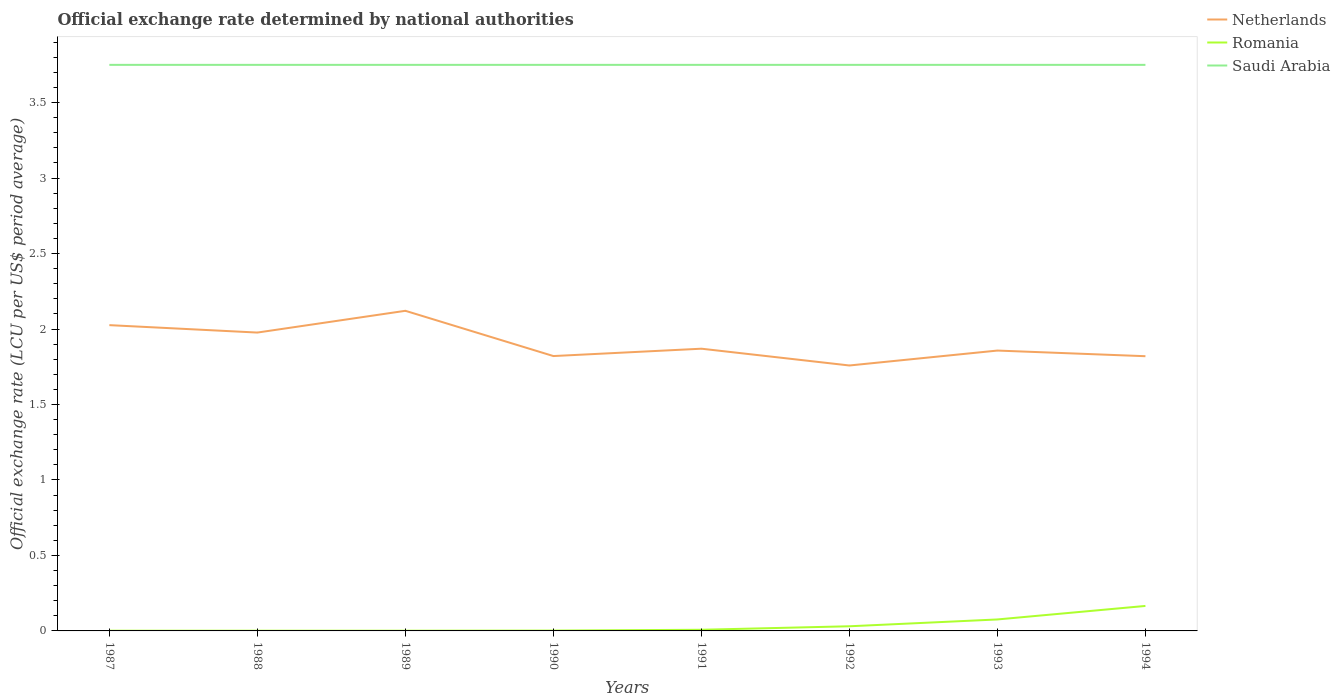Does the line corresponding to Saudi Arabia intersect with the line corresponding to Romania?
Offer a very short reply. No. Is the number of lines equal to the number of legend labels?
Provide a succinct answer. Yes. Across all years, what is the maximum official exchange rate in Netherlands?
Offer a very short reply. 1.76. What is the total official exchange rate in Netherlands in the graph?
Keep it short and to the point. -0.06. What is the difference between the highest and the second highest official exchange rate in Saudi Arabia?
Provide a succinct answer. 0. What is the difference between the highest and the lowest official exchange rate in Netherlands?
Your response must be concise. 3. Is the official exchange rate in Netherlands strictly greater than the official exchange rate in Romania over the years?
Offer a terse response. No. Are the values on the major ticks of Y-axis written in scientific E-notation?
Keep it short and to the point. No. Does the graph contain any zero values?
Provide a short and direct response. No. Does the graph contain grids?
Your answer should be very brief. No. Where does the legend appear in the graph?
Your answer should be very brief. Top right. How are the legend labels stacked?
Offer a terse response. Vertical. What is the title of the graph?
Give a very brief answer. Official exchange rate determined by national authorities. What is the label or title of the X-axis?
Provide a succinct answer. Years. What is the label or title of the Y-axis?
Ensure brevity in your answer.  Official exchange rate (LCU per US$ period average). What is the Official exchange rate (LCU per US$ period average) in Netherlands in 1987?
Your response must be concise. 2.03. What is the Official exchange rate (LCU per US$ period average) of Romania in 1987?
Give a very brief answer. 0. What is the Official exchange rate (LCU per US$ period average) of Saudi Arabia in 1987?
Ensure brevity in your answer.  3.75. What is the Official exchange rate (LCU per US$ period average) in Netherlands in 1988?
Offer a terse response. 1.98. What is the Official exchange rate (LCU per US$ period average) of Romania in 1988?
Your answer should be very brief. 0. What is the Official exchange rate (LCU per US$ period average) in Saudi Arabia in 1988?
Ensure brevity in your answer.  3.75. What is the Official exchange rate (LCU per US$ period average) in Netherlands in 1989?
Your response must be concise. 2.12. What is the Official exchange rate (LCU per US$ period average) in Romania in 1989?
Your response must be concise. 0. What is the Official exchange rate (LCU per US$ period average) in Saudi Arabia in 1989?
Your response must be concise. 3.75. What is the Official exchange rate (LCU per US$ period average) of Netherlands in 1990?
Your response must be concise. 1.82. What is the Official exchange rate (LCU per US$ period average) in Romania in 1990?
Your answer should be compact. 0. What is the Official exchange rate (LCU per US$ period average) in Saudi Arabia in 1990?
Offer a very short reply. 3.75. What is the Official exchange rate (LCU per US$ period average) of Netherlands in 1991?
Provide a short and direct response. 1.87. What is the Official exchange rate (LCU per US$ period average) of Romania in 1991?
Your answer should be very brief. 0.01. What is the Official exchange rate (LCU per US$ period average) of Saudi Arabia in 1991?
Give a very brief answer. 3.75. What is the Official exchange rate (LCU per US$ period average) in Netherlands in 1992?
Your response must be concise. 1.76. What is the Official exchange rate (LCU per US$ period average) in Romania in 1992?
Keep it short and to the point. 0.03. What is the Official exchange rate (LCU per US$ period average) of Saudi Arabia in 1992?
Make the answer very short. 3.75. What is the Official exchange rate (LCU per US$ period average) in Netherlands in 1993?
Make the answer very short. 1.86. What is the Official exchange rate (LCU per US$ period average) in Romania in 1993?
Ensure brevity in your answer.  0.08. What is the Official exchange rate (LCU per US$ period average) in Saudi Arabia in 1993?
Your answer should be compact. 3.75. What is the Official exchange rate (LCU per US$ period average) in Netherlands in 1994?
Provide a succinct answer. 1.82. What is the Official exchange rate (LCU per US$ period average) in Romania in 1994?
Keep it short and to the point. 0.17. What is the Official exchange rate (LCU per US$ period average) in Saudi Arabia in 1994?
Your response must be concise. 3.75. Across all years, what is the maximum Official exchange rate (LCU per US$ period average) in Netherlands?
Provide a short and direct response. 2.12. Across all years, what is the maximum Official exchange rate (LCU per US$ period average) in Romania?
Offer a terse response. 0.17. Across all years, what is the maximum Official exchange rate (LCU per US$ period average) of Saudi Arabia?
Your response must be concise. 3.75. Across all years, what is the minimum Official exchange rate (LCU per US$ period average) of Netherlands?
Your response must be concise. 1.76. Across all years, what is the minimum Official exchange rate (LCU per US$ period average) in Romania?
Keep it short and to the point. 0. Across all years, what is the minimum Official exchange rate (LCU per US$ period average) in Saudi Arabia?
Keep it short and to the point. 3.75. What is the total Official exchange rate (LCU per US$ period average) in Netherlands in the graph?
Your answer should be compact. 15.25. What is the total Official exchange rate (LCU per US$ period average) of Romania in the graph?
Make the answer very short. 0.29. What is the total Official exchange rate (LCU per US$ period average) in Saudi Arabia in the graph?
Offer a terse response. 30. What is the difference between the Official exchange rate (LCU per US$ period average) of Netherlands in 1987 and that in 1988?
Give a very brief answer. 0.05. What is the difference between the Official exchange rate (LCU per US$ period average) in Romania in 1987 and that in 1988?
Make the answer very short. 0. What is the difference between the Official exchange rate (LCU per US$ period average) of Netherlands in 1987 and that in 1989?
Your answer should be very brief. -0.1. What is the difference between the Official exchange rate (LCU per US$ period average) of Romania in 1987 and that in 1989?
Keep it short and to the point. -0. What is the difference between the Official exchange rate (LCU per US$ period average) in Saudi Arabia in 1987 and that in 1989?
Ensure brevity in your answer.  0. What is the difference between the Official exchange rate (LCU per US$ period average) in Netherlands in 1987 and that in 1990?
Give a very brief answer. 0.2. What is the difference between the Official exchange rate (LCU per US$ period average) in Romania in 1987 and that in 1990?
Offer a terse response. -0. What is the difference between the Official exchange rate (LCU per US$ period average) in Saudi Arabia in 1987 and that in 1990?
Your response must be concise. 0. What is the difference between the Official exchange rate (LCU per US$ period average) of Netherlands in 1987 and that in 1991?
Make the answer very short. 0.16. What is the difference between the Official exchange rate (LCU per US$ period average) in Romania in 1987 and that in 1991?
Offer a terse response. -0.01. What is the difference between the Official exchange rate (LCU per US$ period average) of Netherlands in 1987 and that in 1992?
Offer a very short reply. 0.27. What is the difference between the Official exchange rate (LCU per US$ period average) in Romania in 1987 and that in 1992?
Ensure brevity in your answer.  -0.03. What is the difference between the Official exchange rate (LCU per US$ period average) in Netherlands in 1987 and that in 1993?
Your answer should be very brief. 0.17. What is the difference between the Official exchange rate (LCU per US$ period average) of Romania in 1987 and that in 1993?
Make the answer very short. -0.07. What is the difference between the Official exchange rate (LCU per US$ period average) of Netherlands in 1987 and that in 1994?
Provide a short and direct response. 0.21. What is the difference between the Official exchange rate (LCU per US$ period average) of Romania in 1987 and that in 1994?
Give a very brief answer. -0.16. What is the difference between the Official exchange rate (LCU per US$ period average) of Saudi Arabia in 1987 and that in 1994?
Give a very brief answer. 0. What is the difference between the Official exchange rate (LCU per US$ period average) of Netherlands in 1988 and that in 1989?
Your response must be concise. -0.14. What is the difference between the Official exchange rate (LCU per US$ period average) of Romania in 1988 and that in 1989?
Give a very brief answer. -0. What is the difference between the Official exchange rate (LCU per US$ period average) of Netherlands in 1988 and that in 1990?
Offer a terse response. 0.16. What is the difference between the Official exchange rate (LCU per US$ period average) in Romania in 1988 and that in 1990?
Offer a terse response. -0. What is the difference between the Official exchange rate (LCU per US$ period average) in Netherlands in 1988 and that in 1991?
Offer a terse response. 0.11. What is the difference between the Official exchange rate (LCU per US$ period average) in Romania in 1988 and that in 1991?
Ensure brevity in your answer.  -0.01. What is the difference between the Official exchange rate (LCU per US$ period average) of Saudi Arabia in 1988 and that in 1991?
Offer a terse response. 0. What is the difference between the Official exchange rate (LCU per US$ period average) in Netherlands in 1988 and that in 1992?
Your answer should be very brief. 0.22. What is the difference between the Official exchange rate (LCU per US$ period average) of Romania in 1988 and that in 1992?
Your response must be concise. -0.03. What is the difference between the Official exchange rate (LCU per US$ period average) in Saudi Arabia in 1988 and that in 1992?
Give a very brief answer. 0. What is the difference between the Official exchange rate (LCU per US$ period average) in Netherlands in 1988 and that in 1993?
Offer a terse response. 0.12. What is the difference between the Official exchange rate (LCU per US$ period average) in Romania in 1988 and that in 1993?
Your response must be concise. -0.07. What is the difference between the Official exchange rate (LCU per US$ period average) in Saudi Arabia in 1988 and that in 1993?
Your answer should be compact. 0. What is the difference between the Official exchange rate (LCU per US$ period average) in Netherlands in 1988 and that in 1994?
Your answer should be very brief. 0.16. What is the difference between the Official exchange rate (LCU per US$ period average) of Romania in 1988 and that in 1994?
Your answer should be compact. -0.16. What is the difference between the Official exchange rate (LCU per US$ period average) in Saudi Arabia in 1988 and that in 1994?
Make the answer very short. 0. What is the difference between the Official exchange rate (LCU per US$ period average) in Netherlands in 1989 and that in 1990?
Ensure brevity in your answer.  0.3. What is the difference between the Official exchange rate (LCU per US$ period average) of Romania in 1989 and that in 1990?
Provide a succinct answer. -0. What is the difference between the Official exchange rate (LCU per US$ period average) in Saudi Arabia in 1989 and that in 1990?
Provide a succinct answer. 0. What is the difference between the Official exchange rate (LCU per US$ period average) of Netherlands in 1989 and that in 1991?
Give a very brief answer. 0.25. What is the difference between the Official exchange rate (LCU per US$ period average) of Romania in 1989 and that in 1991?
Make the answer very short. -0.01. What is the difference between the Official exchange rate (LCU per US$ period average) of Saudi Arabia in 1989 and that in 1991?
Provide a short and direct response. 0. What is the difference between the Official exchange rate (LCU per US$ period average) in Netherlands in 1989 and that in 1992?
Make the answer very short. 0.36. What is the difference between the Official exchange rate (LCU per US$ period average) in Romania in 1989 and that in 1992?
Ensure brevity in your answer.  -0.03. What is the difference between the Official exchange rate (LCU per US$ period average) of Netherlands in 1989 and that in 1993?
Ensure brevity in your answer.  0.26. What is the difference between the Official exchange rate (LCU per US$ period average) in Romania in 1989 and that in 1993?
Your response must be concise. -0.07. What is the difference between the Official exchange rate (LCU per US$ period average) in Saudi Arabia in 1989 and that in 1993?
Make the answer very short. 0. What is the difference between the Official exchange rate (LCU per US$ period average) in Netherlands in 1989 and that in 1994?
Your response must be concise. 0.3. What is the difference between the Official exchange rate (LCU per US$ period average) in Romania in 1989 and that in 1994?
Ensure brevity in your answer.  -0.16. What is the difference between the Official exchange rate (LCU per US$ period average) in Saudi Arabia in 1989 and that in 1994?
Provide a succinct answer. 0. What is the difference between the Official exchange rate (LCU per US$ period average) in Netherlands in 1990 and that in 1991?
Offer a very short reply. -0.05. What is the difference between the Official exchange rate (LCU per US$ period average) of Romania in 1990 and that in 1991?
Provide a succinct answer. -0.01. What is the difference between the Official exchange rate (LCU per US$ period average) of Netherlands in 1990 and that in 1992?
Make the answer very short. 0.06. What is the difference between the Official exchange rate (LCU per US$ period average) of Romania in 1990 and that in 1992?
Your answer should be compact. -0.03. What is the difference between the Official exchange rate (LCU per US$ period average) of Saudi Arabia in 1990 and that in 1992?
Keep it short and to the point. 0. What is the difference between the Official exchange rate (LCU per US$ period average) in Netherlands in 1990 and that in 1993?
Offer a very short reply. -0.04. What is the difference between the Official exchange rate (LCU per US$ period average) in Romania in 1990 and that in 1993?
Your answer should be very brief. -0.07. What is the difference between the Official exchange rate (LCU per US$ period average) of Saudi Arabia in 1990 and that in 1993?
Offer a terse response. 0. What is the difference between the Official exchange rate (LCU per US$ period average) of Netherlands in 1990 and that in 1994?
Provide a succinct answer. 0. What is the difference between the Official exchange rate (LCU per US$ period average) in Romania in 1990 and that in 1994?
Give a very brief answer. -0.16. What is the difference between the Official exchange rate (LCU per US$ period average) of Saudi Arabia in 1990 and that in 1994?
Your response must be concise. 0. What is the difference between the Official exchange rate (LCU per US$ period average) in Netherlands in 1991 and that in 1992?
Your answer should be compact. 0.11. What is the difference between the Official exchange rate (LCU per US$ period average) in Romania in 1991 and that in 1992?
Offer a very short reply. -0.02. What is the difference between the Official exchange rate (LCU per US$ period average) in Saudi Arabia in 1991 and that in 1992?
Provide a short and direct response. 0. What is the difference between the Official exchange rate (LCU per US$ period average) of Netherlands in 1991 and that in 1993?
Your answer should be very brief. 0.01. What is the difference between the Official exchange rate (LCU per US$ period average) in Romania in 1991 and that in 1993?
Give a very brief answer. -0.07. What is the difference between the Official exchange rate (LCU per US$ period average) in Saudi Arabia in 1991 and that in 1993?
Your answer should be compact. 0. What is the difference between the Official exchange rate (LCU per US$ period average) in Netherlands in 1991 and that in 1994?
Your answer should be very brief. 0.05. What is the difference between the Official exchange rate (LCU per US$ period average) in Romania in 1991 and that in 1994?
Offer a very short reply. -0.16. What is the difference between the Official exchange rate (LCU per US$ period average) of Netherlands in 1992 and that in 1993?
Make the answer very short. -0.1. What is the difference between the Official exchange rate (LCU per US$ period average) in Romania in 1992 and that in 1993?
Your response must be concise. -0.05. What is the difference between the Official exchange rate (LCU per US$ period average) of Saudi Arabia in 1992 and that in 1993?
Ensure brevity in your answer.  0. What is the difference between the Official exchange rate (LCU per US$ period average) of Netherlands in 1992 and that in 1994?
Your answer should be very brief. -0.06. What is the difference between the Official exchange rate (LCU per US$ period average) in Romania in 1992 and that in 1994?
Make the answer very short. -0.13. What is the difference between the Official exchange rate (LCU per US$ period average) in Saudi Arabia in 1992 and that in 1994?
Keep it short and to the point. 0. What is the difference between the Official exchange rate (LCU per US$ period average) of Netherlands in 1993 and that in 1994?
Make the answer very short. 0.04. What is the difference between the Official exchange rate (LCU per US$ period average) in Romania in 1993 and that in 1994?
Offer a terse response. -0.09. What is the difference between the Official exchange rate (LCU per US$ period average) of Saudi Arabia in 1993 and that in 1994?
Give a very brief answer. 0. What is the difference between the Official exchange rate (LCU per US$ period average) in Netherlands in 1987 and the Official exchange rate (LCU per US$ period average) in Romania in 1988?
Your answer should be compact. 2.02. What is the difference between the Official exchange rate (LCU per US$ period average) of Netherlands in 1987 and the Official exchange rate (LCU per US$ period average) of Saudi Arabia in 1988?
Provide a succinct answer. -1.72. What is the difference between the Official exchange rate (LCU per US$ period average) in Romania in 1987 and the Official exchange rate (LCU per US$ period average) in Saudi Arabia in 1988?
Give a very brief answer. -3.75. What is the difference between the Official exchange rate (LCU per US$ period average) of Netherlands in 1987 and the Official exchange rate (LCU per US$ period average) of Romania in 1989?
Make the answer very short. 2.02. What is the difference between the Official exchange rate (LCU per US$ period average) of Netherlands in 1987 and the Official exchange rate (LCU per US$ period average) of Saudi Arabia in 1989?
Offer a very short reply. -1.72. What is the difference between the Official exchange rate (LCU per US$ period average) of Romania in 1987 and the Official exchange rate (LCU per US$ period average) of Saudi Arabia in 1989?
Keep it short and to the point. -3.75. What is the difference between the Official exchange rate (LCU per US$ period average) of Netherlands in 1987 and the Official exchange rate (LCU per US$ period average) of Romania in 1990?
Ensure brevity in your answer.  2.02. What is the difference between the Official exchange rate (LCU per US$ period average) in Netherlands in 1987 and the Official exchange rate (LCU per US$ period average) in Saudi Arabia in 1990?
Make the answer very short. -1.72. What is the difference between the Official exchange rate (LCU per US$ period average) in Romania in 1987 and the Official exchange rate (LCU per US$ period average) in Saudi Arabia in 1990?
Ensure brevity in your answer.  -3.75. What is the difference between the Official exchange rate (LCU per US$ period average) in Netherlands in 1987 and the Official exchange rate (LCU per US$ period average) in Romania in 1991?
Provide a succinct answer. 2.02. What is the difference between the Official exchange rate (LCU per US$ period average) of Netherlands in 1987 and the Official exchange rate (LCU per US$ period average) of Saudi Arabia in 1991?
Ensure brevity in your answer.  -1.72. What is the difference between the Official exchange rate (LCU per US$ period average) of Romania in 1987 and the Official exchange rate (LCU per US$ period average) of Saudi Arabia in 1991?
Your response must be concise. -3.75. What is the difference between the Official exchange rate (LCU per US$ period average) of Netherlands in 1987 and the Official exchange rate (LCU per US$ period average) of Romania in 1992?
Give a very brief answer. 1.99. What is the difference between the Official exchange rate (LCU per US$ period average) of Netherlands in 1987 and the Official exchange rate (LCU per US$ period average) of Saudi Arabia in 1992?
Your response must be concise. -1.72. What is the difference between the Official exchange rate (LCU per US$ period average) in Romania in 1987 and the Official exchange rate (LCU per US$ period average) in Saudi Arabia in 1992?
Offer a terse response. -3.75. What is the difference between the Official exchange rate (LCU per US$ period average) of Netherlands in 1987 and the Official exchange rate (LCU per US$ period average) of Romania in 1993?
Your response must be concise. 1.95. What is the difference between the Official exchange rate (LCU per US$ period average) in Netherlands in 1987 and the Official exchange rate (LCU per US$ period average) in Saudi Arabia in 1993?
Provide a short and direct response. -1.72. What is the difference between the Official exchange rate (LCU per US$ period average) in Romania in 1987 and the Official exchange rate (LCU per US$ period average) in Saudi Arabia in 1993?
Offer a very short reply. -3.75. What is the difference between the Official exchange rate (LCU per US$ period average) of Netherlands in 1987 and the Official exchange rate (LCU per US$ period average) of Romania in 1994?
Offer a very short reply. 1.86. What is the difference between the Official exchange rate (LCU per US$ period average) in Netherlands in 1987 and the Official exchange rate (LCU per US$ period average) in Saudi Arabia in 1994?
Give a very brief answer. -1.72. What is the difference between the Official exchange rate (LCU per US$ period average) of Romania in 1987 and the Official exchange rate (LCU per US$ period average) of Saudi Arabia in 1994?
Your answer should be compact. -3.75. What is the difference between the Official exchange rate (LCU per US$ period average) of Netherlands in 1988 and the Official exchange rate (LCU per US$ period average) of Romania in 1989?
Provide a succinct answer. 1.98. What is the difference between the Official exchange rate (LCU per US$ period average) in Netherlands in 1988 and the Official exchange rate (LCU per US$ period average) in Saudi Arabia in 1989?
Provide a succinct answer. -1.77. What is the difference between the Official exchange rate (LCU per US$ period average) in Romania in 1988 and the Official exchange rate (LCU per US$ period average) in Saudi Arabia in 1989?
Offer a terse response. -3.75. What is the difference between the Official exchange rate (LCU per US$ period average) of Netherlands in 1988 and the Official exchange rate (LCU per US$ period average) of Romania in 1990?
Your answer should be very brief. 1.97. What is the difference between the Official exchange rate (LCU per US$ period average) of Netherlands in 1988 and the Official exchange rate (LCU per US$ period average) of Saudi Arabia in 1990?
Make the answer very short. -1.77. What is the difference between the Official exchange rate (LCU per US$ period average) in Romania in 1988 and the Official exchange rate (LCU per US$ period average) in Saudi Arabia in 1990?
Offer a terse response. -3.75. What is the difference between the Official exchange rate (LCU per US$ period average) of Netherlands in 1988 and the Official exchange rate (LCU per US$ period average) of Romania in 1991?
Your response must be concise. 1.97. What is the difference between the Official exchange rate (LCU per US$ period average) in Netherlands in 1988 and the Official exchange rate (LCU per US$ period average) in Saudi Arabia in 1991?
Your answer should be very brief. -1.77. What is the difference between the Official exchange rate (LCU per US$ period average) in Romania in 1988 and the Official exchange rate (LCU per US$ period average) in Saudi Arabia in 1991?
Your answer should be very brief. -3.75. What is the difference between the Official exchange rate (LCU per US$ period average) of Netherlands in 1988 and the Official exchange rate (LCU per US$ period average) of Romania in 1992?
Offer a very short reply. 1.95. What is the difference between the Official exchange rate (LCU per US$ period average) of Netherlands in 1988 and the Official exchange rate (LCU per US$ period average) of Saudi Arabia in 1992?
Make the answer very short. -1.77. What is the difference between the Official exchange rate (LCU per US$ period average) in Romania in 1988 and the Official exchange rate (LCU per US$ period average) in Saudi Arabia in 1992?
Your answer should be very brief. -3.75. What is the difference between the Official exchange rate (LCU per US$ period average) of Netherlands in 1988 and the Official exchange rate (LCU per US$ period average) of Romania in 1993?
Ensure brevity in your answer.  1.9. What is the difference between the Official exchange rate (LCU per US$ period average) in Netherlands in 1988 and the Official exchange rate (LCU per US$ period average) in Saudi Arabia in 1993?
Ensure brevity in your answer.  -1.77. What is the difference between the Official exchange rate (LCU per US$ period average) in Romania in 1988 and the Official exchange rate (LCU per US$ period average) in Saudi Arabia in 1993?
Ensure brevity in your answer.  -3.75. What is the difference between the Official exchange rate (LCU per US$ period average) of Netherlands in 1988 and the Official exchange rate (LCU per US$ period average) of Romania in 1994?
Your answer should be compact. 1.81. What is the difference between the Official exchange rate (LCU per US$ period average) in Netherlands in 1988 and the Official exchange rate (LCU per US$ period average) in Saudi Arabia in 1994?
Your answer should be compact. -1.77. What is the difference between the Official exchange rate (LCU per US$ period average) in Romania in 1988 and the Official exchange rate (LCU per US$ period average) in Saudi Arabia in 1994?
Your answer should be very brief. -3.75. What is the difference between the Official exchange rate (LCU per US$ period average) of Netherlands in 1989 and the Official exchange rate (LCU per US$ period average) of Romania in 1990?
Your answer should be very brief. 2.12. What is the difference between the Official exchange rate (LCU per US$ period average) in Netherlands in 1989 and the Official exchange rate (LCU per US$ period average) in Saudi Arabia in 1990?
Provide a succinct answer. -1.63. What is the difference between the Official exchange rate (LCU per US$ period average) of Romania in 1989 and the Official exchange rate (LCU per US$ period average) of Saudi Arabia in 1990?
Offer a very short reply. -3.75. What is the difference between the Official exchange rate (LCU per US$ period average) of Netherlands in 1989 and the Official exchange rate (LCU per US$ period average) of Romania in 1991?
Your response must be concise. 2.11. What is the difference between the Official exchange rate (LCU per US$ period average) of Netherlands in 1989 and the Official exchange rate (LCU per US$ period average) of Saudi Arabia in 1991?
Offer a terse response. -1.63. What is the difference between the Official exchange rate (LCU per US$ period average) in Romania in 1989 and the Official exchange rate (LCU per US$ period average) in Saudi Arabia in 1991?
Provide a succinct answer. -3.75. What is the difference between the Official exchange rate (LCU per US$ period average) in Netherlands in 1989 and the Official exchange rate (LCU per US$ period average) in Romania in 1992?
Provide a short and direct response. 2.09. What is the difference between the Official exchange rate (LCU per US$ period average) in Netherlands in 1989 and the Official exchange rate (LCU per US$ period average) in Saudi Arabia in 1992?
Your answer should be very brief. -1.63. What is the difference between the Official exchange rate (LCU per US$ period average) of Romania in 1989 and the Official exchange rate (LCU per US$ period average) of Saudi Arabia in 1992?
Offer a terse response. -3.75. What is the difference between the Official exchange rate (LCU per US$ period average) of Netherlands in 1989 and the Official exchange rate (LCU per US$ period average) of Romania in 1993?
Your answer should be compact. 2.04. What is the difference between the Official exchange rate (LCU per US$ period average) of Netherlands in 1989 and the Official exchange rate (LCU per US$ period average) of Saudi Arabia in 1993?
Give a very brief answer. -1.63. What is the difference between the Official exchange rate (LCU per US$ period average) of Romania in 1989 and the Official exchange rate (LCU per US$ period average) of Saudi Arabia in 1993?
Your response must be concise. -3.75. What is the difference between the Official exchange rate (LCU per US$ period average) of Netherlands in 1989 and the Official exchange rate (LCU per US$ period average) of Romania in 1994?
Ensure brevity in your answer.  1.96. What is the difference between the Official exchange rate (LCU per US$ period average) in Netherlands in 1989 and the Official exchange rate (LCU per US$ period average) in Saudi Arabia in 1994?
Offer a terse response. -1.63. What is the difference between the Official exchange rate (LCU per US$ period average) in Romania in 1989 and the Official exchange rate (LCU per US$ period average) in Saudi Arabia in 1994?
Keep it short and to the point. -3.75. What is the difference between the Official exchange rate (LCU per US$ period average) of Netherlands in 1990 and the Official exchange rate (LCU per US$ period average) of Romania in 1991?
Offer a very short reply. 1.81. What is the difference between the Official exchange rate (LCU per US$ period average) of Netherlands in 1990 and the Official exchange rate (LCU per US$ period average) of Saudi Arabia in 1991?
Your response must be concise. -1.93. What is the difference between the Official exchange rate (LCU per US$ period average) of Romania in 1990 and the Official exchange rate (LCU per US$ period average) of Saudi Arabia in 1991?
Provide a short and direct response. -3.75. What is the difference between the Official exchange rate (LCU per US$ period average) of Netherlands in 1990 and the Official exchange rate (LCU per US$ period average) of Romania in 1992?
Provide a short and direct response. 1.79. What is the difference between the Official exchange rate (LCU per US$ period average) of Netherlands in 1990 and the Official exchange rate (LCU per US$ period average) of Saudi Arabia in 1992?
Keep it short and to the point. -1.93. What is the difference between the Official exchange rate (LCU per US$ period average) of Romania in 1990 and the Official exchange rate (LCU per US$ period average) of Saudi Arabia in 1992?
Ensure brevity in your answer.  -3.75. What is the difference between the Official exchange rate (LCU per US$ period average) in Netherlands in 1990 and the Official exchange rate (LCU per US$ period average) in Romania in 1993?
Your response must be concise. 1.74. What is the difference between the Official exchange rate (LCU per US$ period average) in Netherlands in 1990 and the Official exchange rate (LCU per US$ period average) in Saudi Arabia in 1993?
Provide a succinct answer. -1.93. What is the difference between the Official exchange rate (LCU per US$ period average) in Romania in 1990 and the Official exchange rate (LCU per US$ period average) in Saudi Arabia in 1993?
Give a very brief answer. -3.75. What is the difference between the Official exchange rate (LCU per US$ period average) of Netherlands in 1990 and the Official exchange rate (LCU per US$ period average) of Romania in 1994?
Your answer should be compact. 1.66. What is the difference between the Official exchange rate (LCU per US$ period average) in Netherlands in 1990 and the Official exchange rate (LCU per US$ period average) in Saudi Arabia in 1994?
Provide a succinct answer. -1.93. What is the difference between the Official exchange rate (LCU per US$ period average) of Romania in 1990 and the Official exchange rate (LCU per US$ period average) of Saudi Arabia in 1994?
Provide a succinct answer. -3.75. What is the difference between the Official exchange rate (LCU per US$ period average) in Netherlands in 1991 and the Official exchange rate (LCU per US$ period average) in Romania in 1992?
Make the answer very short. 1.84. What is the difference between the Official exchange rate (LCU per US$ period average) in Netherlands in 1991 and the Official exchange rate (LCU per US$ period average) in Saudi Arabia in 1992?
Ensure brevity in your answer.  -1.88. What is the difference between the Official exchange rate (LCU per US$ period average) of Romania in 1991 and the Official exchange rate (LCU per US$ period average) of Saudi Arabia in 1992?
Give a very brief answer. -3.74. What is the difference between the Official exchange rate (LCU per US$ period average) of Netherlands in 1991 and the Official exchange rate (LCU per US$ period average) of Romania in 1993?
Offer a terse response. 1.79. What is the difference between the Official exchange rate (LCU per US$ period average) in Netherlands in 1991 and the Official exchange rate (LCU per US$ period average) in Saudi Arabia in 1993?
Offer a terse response. -1.88. What is the difference between the Official exchange rate (LCU per US$ period average) of Romania in 1991 and the Official exchange rate (LCU per US$ period average) of Saudi Arabia in 1993?
Offer a very short reply. -3.74. What is the difference between the Official exchange rate (LCU per US$ period average) of Netherlands in 1991 and the Official exchange rate (LCU per US$ period average) of Romania in 1994?
Make the answer very short. 1.7. What is the difference between the Official exchange rate (LCU per US$ period average) in Netherlands in 1991 and the Official exchange rate (LCU per US$ period average) in Saudi Arabia in 1994?
Provide a short and direct response. -1.88. What is the difference between the Official exchange rate (LCU per US$ period average) in Romania in 1991 and the Official exchange rate (LCU per US$ period average) in Saudi Arabia in 1994?
Provide a succinct answer. -3.74. What is the difference between the Official exchange rate (LCU per US$ period average) in Netherlands in 1992 and the Official exchange rate (LCU per US$ period average) in Romania in 1993?
Ensure brevity in your answer.  1.68. What is the difference between the Official exchange rate (LCU per US$ period average) of Netherlands in 1992 and the Official exchange rate (LCU per US$ period average) of Saudi Arabia in 1993?
Make the answer very short. -1.99. What is the difference between the Official exchange rate (LCU per US$ period average) in Romania in 1992 and the Official exchange rate (LCU per US$ period average) in Saudi Arabia in 1993?
Your answer should be very brief. -3.72. What is the difference between the Official exchange rate (LCU per US$ period average) of Netherlands in 1992 and the Official exchange rate (LCU per US$ period average) of Romania in 1994?
Offer a terse response. 1.59. What is the difference between the Official exchange rate (LCU per US$ period average) in Netherlands in 1992 and the Official exchange rate (LCU per US$ period average) in Saudi Arabia in 1994?
Give a very brief answer. -1.99. What is the difference between the Official exchange rate (LCU per US$ period average) in Romania in 1992 and the Official exchange rate (LCU per US$ period average) in Saudi Arabia in 1994?
Offer a very short reply. -3.72. What is the difference between the Official exchange rate (LCU per US$ period average) of Netherlands in 1993 and the Official exchange rate (LCU per US$ period average) of Romania in 1994?
Provide a short and direct response. 1.69. What is the difference between the Official exchange rate (LCU per US$ period average) in Netherlands in 1993 and the Official exchange rate (LCU per US$ period average) in Saudi Arabia in 1994?
Offer a terse response. -1.89. What is the difference between the Official exchange rate (LCU per US$ period average) of Romania in 1993 and the Official exchange rate (LCU per US$ period average) of Saudi Arabia in 1994?
Your response must be concise. -3.67. What is the average Official exchange rate (LCU per US$ period average) of Netherlands per year?
Keep it short and to the point. 1.91. What is the average Official exchange rate (LCU per US$ period average) in Romania per year?
Offer a very short reply. 0.04. What is the average Official exchange rate (LCU per US$ period average) of Saudi Arabia per year?
Offer a very short reply. 3.75. In the year 1987, what is the difference between the Official exchange rate (LCU per US$ period average) in Netherlands and Official exchange rate (LCU per US$ period average) in Romania?
Provide a short and direct response. 2.02. In the year 1987, what is the difference between the Official exchange rate (LCU per US$ period average) of Netherlands and Official exchange rate (LCU per US$ period average) of Saudi Arabia?
Provide a succinct answer. -1.72. In the year 1987, what is the difference between the Official exchange rate (LCU per US$ period average) of Romania and Official exchange rate (LCU per US$ period average) of Saudi Arabia?
Make the answer very short. -3.75. In the year 1988, what is the difference between the Official exchange rate (LCU per US$ period average) of Netherlands and Official exchange rate (LCU per US$ period average) of Romania?
Your answer should be very brief. 1.98. In the year 1988, what is the difference between the Official exchange rate (LCU per US$ period average) of Netherlands and Official exchange rate (LCU per US$ period average) of Saudi Arabia?
Your response must be concise. -1.77. In the year 1988, what is the difference between the Official exchange rate (LCU per US$ period average) of Romania and Official exchange rate (LCU per US$ period average) of Saudi Arabia?
Provide a succinct answer. -3.75. In the year 1989, what is the difference between the Official exchange rate (LCU per US$ period average) of Netherlands and Official exchange rate (LCU per US$ period average) of Romania?
Provide a succinct answer. 2.12. In the year 1989, what is the difference between the Official exchange rate (LCU per US$ period average) in Netherlands and Official exchange rate (LCU per US$ period average) in Saudi Arabia?
Your answer should be compact. -1.63. In the year 1989, what is the difference between the Official exchange rate (LCU per US$ period average) in Romania and Official exchange rate (LCU per US$ period average) in Saudi Arabia?
Give a very brief answer. -3.75. In the year 1990, what is the difference between the Official exchange rate (LCU per US$ period average) in Netherlands and Official exchange rate (LCU per US$ period average) in Romania?
Make the answer very short. 1.82. In the year 1990, what is the difference between the Official exchange rate (LCU per US$ period average) of Netherlands and Official exchange rate (LCU per US$ period average) of Saudi Arabia?
Your answer should be very brief. -1.93. In the year 1990, what is the difference between the Official exchange rate (LCU per US$ period average) of Romania and Official exchange rate (LCU per US$ period average) of Saudi Arabia?
Make the answer very short. -3.75. In the year 1991, what is the difference between the Official exchange rate (LCU per US$ period average) in Netherlands and Official exchange rate (LCU per US$ period average) in Romania?
Give a very brief answer. 1.86. In the year 1991, what is the difference between the Official exchange rate (LCU per US$ period average) in Netherlands and Official exchange rate (LCU per US$ period average) in Saudi Arabia?
Offer a very short reply. -1.88. In the year 1991, what is the difference between the Official exchange rate (LCU per US$ period average) of Romania and Official exchange rate (LCU per US$ period average) of Saudi Arabia?
Your answer should be very brief. -3.74. In the year 1992, what is the difference between the Official exchange rate (LCU per US$ period average) in Netherlands and Official exchange rate (LCU per US$ period average) in Romania?
Ensure brevity in your answer.  1.73. In the year 1992, what is the difference between the Official exchange rate (LCU per US$ period average) of Netherlands and Official exchange rate (LCU per US$ period average) of Saudi Arabia?
Your response must be concise. -1.99. In the year 1992, what is the difference between the Official exchange rate (LCU per US$ period average) of Romania and Official exchange rate (LCU per US$ period average) of Saudi Arabia?
Give a very brief answer. -3.72. In the year 1993, what is the difference between the Official exchange rate (LCU per US$ period average) of Netherlands and Official exchange rate (LCU per US$ period average) of Romania?
Your answer should be compact. 1.78. In the year 1993, what is the difference between the Official exchange rate (LCU per US$ period average) of Netherlands and Official exchange rate (LCU per US$ period average) of Saudi Arabia?
Provide a succinct answer. -1.89. In the year 1993, what is the difference between the Official exchange rate (LCU per US$ period average) in Romania and Official exchange rate (LCU per US$ period average) in Saudi Arabia?
Offer a very short reply. -3.67. In the year 1994, what is the difference between the Official exchange rate (LCU per US$ period average) of Netherlands and Official exchange rate (LCU per US$ period average) of Romania?
Provide a succinct answer. 1.65. In the year 1994, what is the difference between the Official exchange rate (LCU per US$ period average) of Netherlands and Official exchange rate (LCU per US$ period average) of Saudi Arabia?
Provide a short and direct response. -1.93. In the year 1994, what is the difference between the Official exchange rate (LCU per US$ period average) of Romania and Official exchange rate (LCU per US$ period average) of Saudi Arabia?
Your response must be concise. -3.58. What is the ratio of the Official exchange rate (LCU per US$ period average) of Netherlands in 1987 to that in 1988?
Your answer should be very brief. 1.02. What is the ratio of the Official exchange rate (LCU per US$ period average) of Romania in 1987 to that in 1988?
Your answer should be compact. 1.02. What is the ratio of the Official exchange rate (LCU per US$ period average) in Netherlands in 1987 to that in 1989?
Your answer should be compact. 0.96. What is the ratio of the Official exchange rate (LCU per US$ period average) of Romania in 1987 to that in 1989?
Provide a succinct answer. 0.98. What is the ratio of the Official exchange rate (LCU per US$ period average) in Saudi Arabia in 1987 to that in 1989?
Make the answer very short. 1. What is the ratio of the Official exchange rate (LCU per US$ period average) of Netherlands in 1987 to that in 1990?
Provide a short and direct response. 1.11. What is the ratio of the Official exchange rate (LCU per US$ period average) in Romania in 1987 to that in 1990?
Make the answer very short. 0.65. What is the ratio of the Official exchange rate (LCU per US$ period average) of Saudi Arabia in 1987 to that in 1990?
Make the answer very short. 1. What is the ratio of the Official exchange rate (LCU per US$ period average) in Netherlands in 1987 to that in 1991?
Provide a short and direct response. 1.08. What is the ratio of the Official exchange rate (LCU per US$ period average) of Romania in 1987 to that in 1991?
Offer a terse response. 0.19. What is the ratio of the Official exchange rate (LCU per US$ period average) in Saudi Arabia in 1987 to that in 1991?
Keep it short and to the point. 1. What is the ratio of the Official exchange rate (LCU per US$ period average) of Netherlands in 1987 to that in 1992?
Offer a terse response. 1.15. What is the ratio of the Official exchange rate (LCU per US$ period average) of Romania in 1987 to that in 1992?
Give a very brief answer. 0.05. What is the ratio of the Official exchange rate (LCU per US$ period average) of Saudi Arabia in 1987 to that in 1992?
Your answer should be compact. 1. What is the ratio of the Official exchange rate (LCU per US$ period average) of Netherlands in 1987 to that in 1993?
Keep it short and to the point. 1.09. What is the ratio of the Official exchange rate (LCU per US$ period average) of Romania in 1987 to that in 1993?
Give a very brief answer. 0.02. What is the ratio of the Official exchange rate (LCU per US$ period average) of Netherlands in 1987 to that in 1994?
Give a very brief answer. 1.11. What is the ratio of the Official exchange rate (LCU per US$ period average) in Romania in 1987 to that in 1994?
Your answer should be compact. 0.01. What is the ratio of the Official exchange rate (LCU per US$ period average) in Saudi Arabia in 1987 to that in 1994?
Your response must be concise. 1. What is the ratio of the Official exchange rate (LCU per US$ period average) of Netherlands in 1988 to that in 1989?
Keep it short and to the point. 0.93. What is the ratio of the Official exchange rate (LCU per US$ period average) in Romania in 1988 to that in 1989?
Give a very brief answer. 0.96. What is the ratio of the Official exchange rate (LCU per US$ period average) in Netherlands in 1988 to that in 1990?
Your response must be concise. 1.09. What is the ratio of the Official exchange rate (LCU per US$ period average) in Romania in 1988 to that in 1990?
Your response must be concise. 0.64. What is the ratio of the Official exchange rate (LCU per US$ period average) of Netherlands in 1988 to that in 1991?
Give a very brief answer. 1.06. What is the ratio of the Official exchange rate (LCU per US$ period average) of Romania in 1988 to that in 1991?
Offer a very short reply. 0.19. What is the ratio of the Official exchange rate (LCU per US$ period average) of Saudi Arabia in 1988 to that in 1991?
Your answer should be very brief. 1. What is the ratio of the Official exchange rate (LCU per US$ period average) of Netherlands in 1988 to that in 1992?
Ensure brevity in your answer.  1.12. What is the ratio of the Official exchange rate (LCU per US$ period average) of Romania in 1988 to that in 1992?
Your answer should be compact. 0.05. What is the ratio of the Official exchange rate (LCU per US$ period average) of Netherlands in 1988 to that in 1993?
Your answer should be very brief. 1.06. What is the ratio of the Official exchange rate (LCU per US$ period average) in Romania in 1988 to that in 1993?
Give a very brief answer. 0.02. What is the ratio of the Official exchange rate (LCU per US$ period average) in Netherlands in 1988 to that in 1994?
Offer a terse response. 1.09. What is the ratio of the Official exchange rate (LCU per US$ period average) in Romania in 1988 to that in 1994?
Give a very brief answer. 0.01. What is the ratio of the Official exchange rate (LCU per US$ period average) of Saudi Arabia in 1988 to that in 1994?
Give a very brief answer. 1. What is the ratio of the Official exchange rate (LCU per US$ period average) in Netherlands in 1989 to that in 1990?
Provide a succinct answer. 1.16. What is the ratio of the Official exchange rate (LCU per US$ period average) of Romania in 1989 to that in 1990?
Your response must be concise. 0.67. What is the ratio of the Official exchange rate (LCU per US$ period average) in Netherlands in 1989 to that in 1991?
Provide a short and direct response. 1.13. What is the ratio of the Official exchange rate (LCU per US$ period average) of Romania in 1989 to that in 1991?
Give a very brief answer. 0.2. What is the ratio of the Official exchange rate (LCU per US$ period average) of Netherlands in 1989 to that in 1992?
Keep it short and to the point. 1.21. What is the ratio of the Official exchange rate (LCU per US$ period average) of Romania in 1989 to that in 1992?
Give a very brief answer. 0.05. What is the ratio of the Official exchange rate (LCU per US$ period average) of Saudi Arabia in 1989 to that in 1992?
Ensure brevity in your answer.  1. What is the ratio of the Official exchange rate (LCU per US$ period average) of Netherlands in 1989 to that in 1993?
Ensure brevity in your answer.  1.14. What is the ratio of the Official exchange rate (LCU per US$ period average) in Romania in 1989 to that in 1993?
Your answer should be compact. 0.02. What is the ratio of the Official exchange rate (LCU per US$ period average) in Netherlands in 1989 to that in 1994?
Give a very brief answer. 1.17. What is the ratio of the Official exchange rate (LCU per US$ period average) in Romania in 1989 to that in 1994?
Make the answer very short. 0.01. What is the ratio of the Official exchange rate (LCU per US$ period average) of Saudi Arabia in 1989 to that in 1994?
Provide a short and direct response. 1. What is the ratio of the Official exchange rate (LCU per US$ period average) in Netherlands in 1990 to that in 1991?
Keep it short and to the point. 0.97. What is the ratio of the Official exchange rate (LCU per US$ period average) of Romania in 1990 to that in 1991?
Make the answer very short. 0.29. What is the ratio of the Official exchange rate (LCU per US$ period average) of Saudi Arabia in 1990 to that in 1991?
Offer a very short reply. 1. What is the ratio of the Official exchange rate (LCU per US$ period average) in Netherlands in 1990 to that in 1992?
Your answer should be compact. 1.04. What is the ratio of the Official exchange rate (LCU per US$ period average) of Romania in 1990 to that in 1992?
Your response must be concise. 0.07. What is the ratio of the Official exchange rate (LCU per US$ period average) in Netherlands in 1990 to that in 1993?
Give a very brief answer. 0.98. What is the ratio of the Official exchange rate (LCU per US$ period average) of Romania in 1990 to that in 1993?
Offer a very short reply. 0.03. What is the ratio of the Official exchange rate (LCU per US$ period average) in Saudi Arabia in 1990 to that in 1993?
Your response must be concise. 1. What is the ratio of the Official exchange rate (LCU per US$ period average) in Netherlands in 1990 to that in 1994?
Offer a terse response. 1. What is the ratio of the Official exchange rate (LCU per US$ period average) in Romania in 1990 to that in 1994?
Offer a very short reply. 0.01. What is the ratio of the Official exchange rate (LCU per US$ period average) of Netherlands in 1991 to that in 1992?
Provide a short and direct response. 1.06. What is the ratio of the Official exchange rate (LCU per US$ period average) of Romania in 1991 to that in 1992?
Ensure brevity in your answer.  0.25. What is the ratio of the Official exchange rate (LCU per US$ period average) of Romania in 1991 to that in 1993?
Give a very brief answer. 0.1. What is the ratio of the Official exchange rate (LCU per US$ period average) of Netherlands in 1991 to that in 1994?
Your answer should be very brief. 1.03. What is the ratio of the Official exchange rate (LCU per US$ period average) in Romania in 1991 to that in 1994?
Your response must be concise. 0.05. What is the ratio of the Official exchange rate (LCU per US$ period average) of Saudi Arabia in 1991 to that in 1994?
Ensure brevity in your answer.  1. What is the ratio of the Official exchange rate (LCU per US$ period average) of Netherlands in 1992 to that in 1993?
Your answer should be compact. 0.95. What is the ratio of the Official exchange rate (LCU per US$ period average) in Romania in 1992 to that in 1993?
Keep it short and to the point. 0.41. What is the ratio of the Official exchange rate (LCU per US$ period average) in Saudi Arabia in 1992 to that in 1993?
Keep it short and to the point. 1. What is the ratio of the Official exchange rate (LCU per US$ period average) of Netherlands in 1992 to that in 1994?
Give a very brief answer. 0.97. What is the ratio of the Official exchange rate (LCU per US$ period average) of Romania in 1992 to that in 1994?
Your response must be concise. 0.19. What is the ratio of the Official exchange rate (LCU per US$ period average) of Saudi Arabia in 1992 to that in 1994?
Offer a very short reply. 1. What is the ratio of the Official exchange rate (LCU per US$ period average) of Netherlands in 1993 to that in 1994?
Your response must be concise. 1.02. What is the ratio of the Official exchange rate (LCU per US$ period average) of Romania in 1993 to that in 1994?
Provide a short and direct response. 0.46. What is the ratio of the Official exchange rate (LCU per US$ period average) of Saudi Arabia in 1993 to that in 1994?
Give a very brief answer. 1. What is the difference between the highest and the second highest Official exchange rate (LCU per US$ period average) in Netherlands?
Provide a short and direct response. 0.1. What is the difference between the highest and the second highest Official exchange rate (LCU per US$ period average) of Romania?
Your response must be concise. 0.09. What is the difference between the highest and the second highest Official exchange rate (LCU per US$ period average) in Saudi Arabia?
Offer a terse response. 0. What is the difference between the highest and the lowest Official exchange rate (LCU per US$ period average) in Netherlands?
Make the answer very short. 0.36. What is the difference between the highest and the lowest Official exchange rate (LCU per US$ period average) of Romania?
Provide a short and direct response. 0.16. 